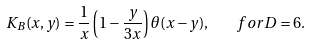<formula> <loc_0><loc_0><loc_500><loc_500>K _ { B } ( x , y ) = \frac { 1 } { x } \left ( 1 - \frac { y } { 3 x } \right ) \theta ( x - y ) , \quad f o r D = 6 .</formula> 